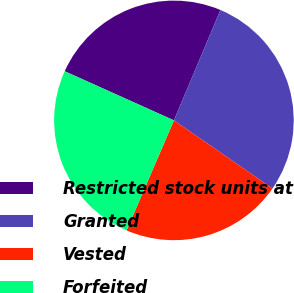Convert chart to OTSL. <chart><loc_0><loc_0><loc_500><loc_500><pie_chart><fcel>Restricted stock units at<fcel>Granted<fcel>Vested<fcel>Forfeited<nl><fcel>24.62%<fcel>28.28%<fcel>21.85%<fcel>25.26%<nl></chart> 